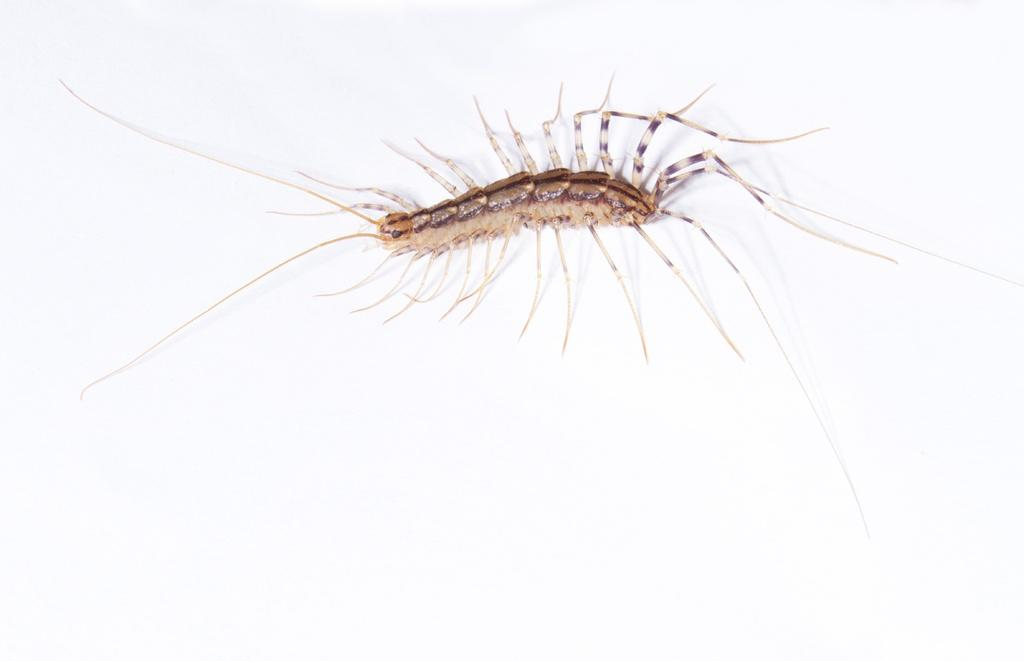What type of creature is present in the image? There is an insect in the image. What is the insect resting on in the image? The insect is on a white surface. What type of police equipment can be seen in the image? There is no police equipment present in the image; it features an insect on a white surface. What type of flesh is visible in the image? There is no flesh present in the image; it features an insect on a white surface. 